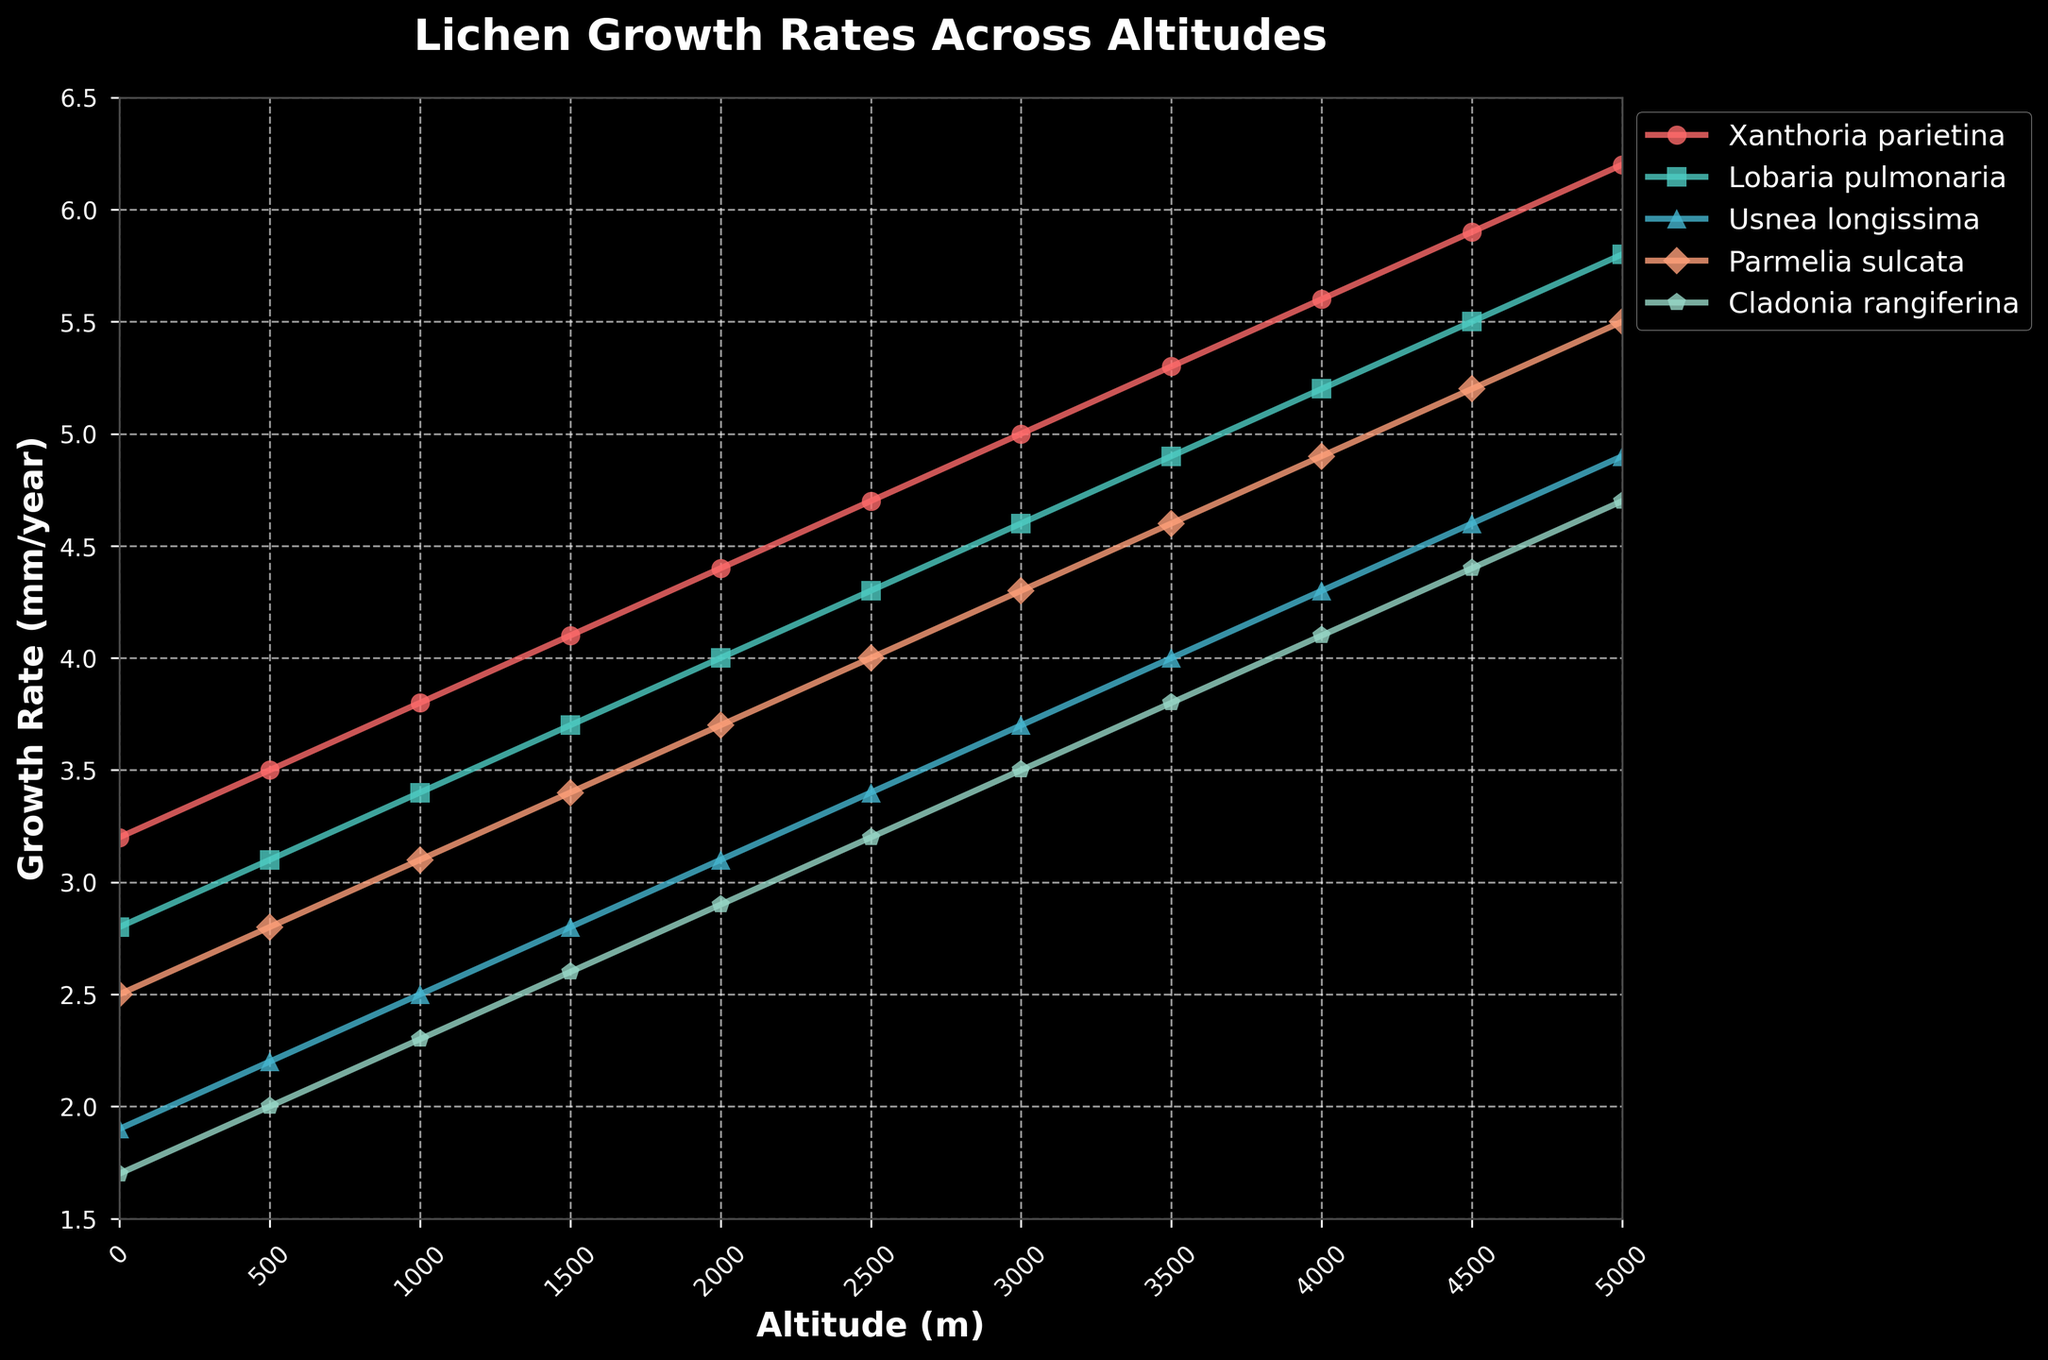What is the growth rate of Xanthoria parietina at an altitude of 4000 meters? The graph shows the growth rate of Xanthoria parietina at each altitude. At 4000 meters, the growth rate is represented by the red line, which is near the label 5.6 on the y-axis.
Answer: 5.6 Which species has the highest growth rate at 2500 meters? We need to compare the growth rates of all species at 2500 meters. According to the lines on the graph at this altitude, Xanthoria parietina has the highest growth rate, indicated by the highest position on the y-axis for this altitude.
Answer: Xanthoria parietina At what altitude do Cladonia rangiferina and Usnea longissima have the same growth rate? Cladonia rangiferina and Usnea longissima have intersecting growth rate lines. By following these lines, we see that they intersect at 2000 meters, indicating equal growth rates.
Answer: 2000 meters What is the difference in growth rates between Lobaria pulmonaria and Parmelia sulcata at 4500 meters? At 4500 meters, Lobaria pulmonaria has a growth rate of 5.5, and Parmelia sulcata has a growth rate of 5.2. Subtracting, 5.5 - 5.2 = 0.3.
Answer: 0.3 Which species shows the least variability in growth rate across the altitudes? Least variability is indicated by the flattest line. By comparing the slopes of the lines, Cladonia rangiferina shows the least slope change from 1.7 to 4.7, suggesting the lowest variability.
Answer: Cladonia rangiferina What is the average growth rate of Parmelia sulcata across all altitudes? Summing the growth rates from 0m to 5000m for Parmelia sulcata: (2.5 + 2.8 + 3.1 + 3.4 + 3.7 + 4.0 + 4.3 + 4.6 + 4.9 + 5.2 + 5.5) = 43 and dividing by 11 (number of data points). Thus, 43 / 11 ≈ 3.91.
Answer: 3.91 Does any lichen species show a decreasing growth trend with increasing altitude? We can check the direction of lines for each lichen species. All species show increasing growth rates as altitude increases, hence no species shows a decreasing trend.
Answer: No At which altitude does Lobaria pulmonaria’s growth rate surpass that of Parmelia sulcata for the first time? Following the lines for both species, we can see that Lobaria pulmonaria surpasses Parmelia sulcata at around 1500 meters.
Answer: 1500 meters 